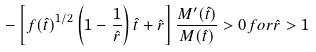Convert formula to latex. <formula><loc_0><loc_0><loc_500><loc_500>- \left [ { f ( \hat { t } ) } ^ { 1 / 2 } \left ( 1 - \frac { 1 } { \hat { r } } \right ) \hat { t } + \hat { r } \right ] \frac { M ^ { \prime } ( \hat { t } ) } { M ( \hat { t } ) } > 0 f o r \hat { r } > 1</formula> 